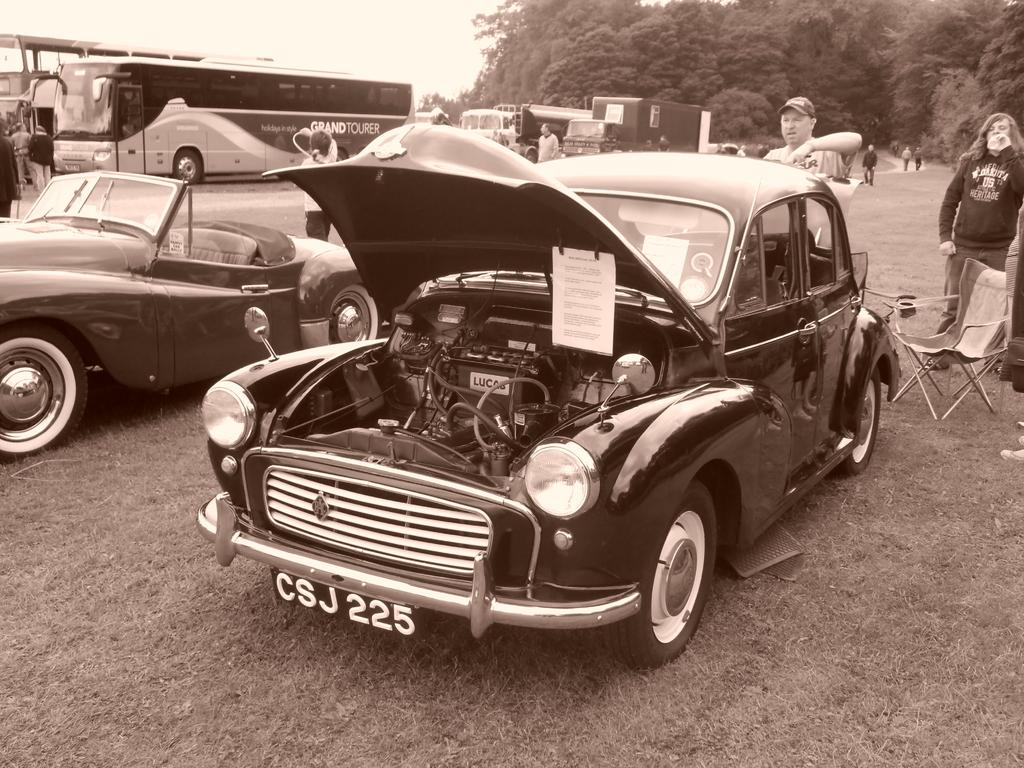What can be seen in the foreground of the image? There are vehicles in the foreground of the image. What is located in the background of the image? In the background, there is a chair, persons standing on the ground, additional vehicles, trees, and the sky. How many types of objects are present in the background? There are at least five types of objects present in the background: a chair, persons, vehicles, trees, and the sky. What type of spring is visible in the image? There is no spring present in the image. Is the image taken during a rainy day? The provided facts do not mention any rain, so it cannot be determined if the image was taken during a rainy day. 